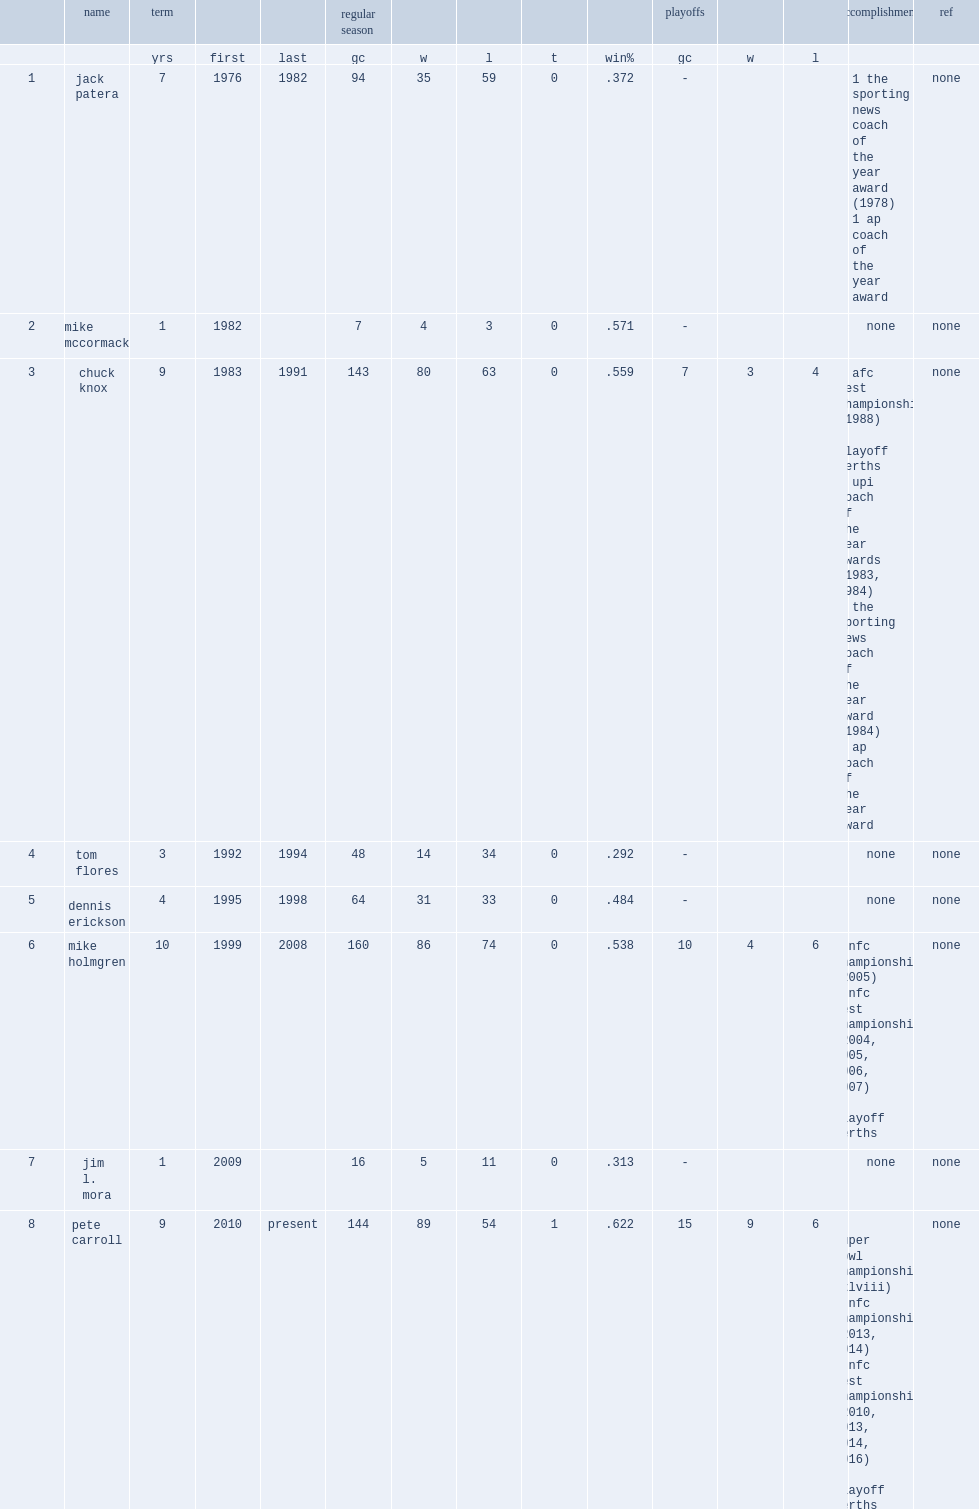What was the winning percentage of seattle seahawks tom flores coached? 0.292. 